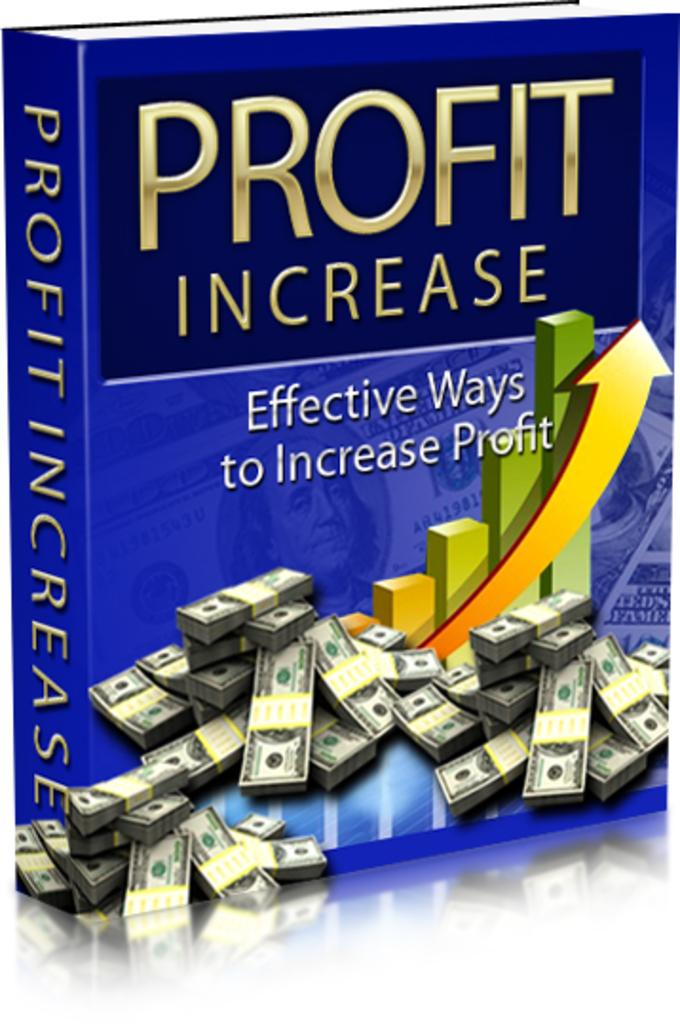<image>
Write a terse but informative summary of the picture. A book called Profit Increase features stacks of cash on the cover. 